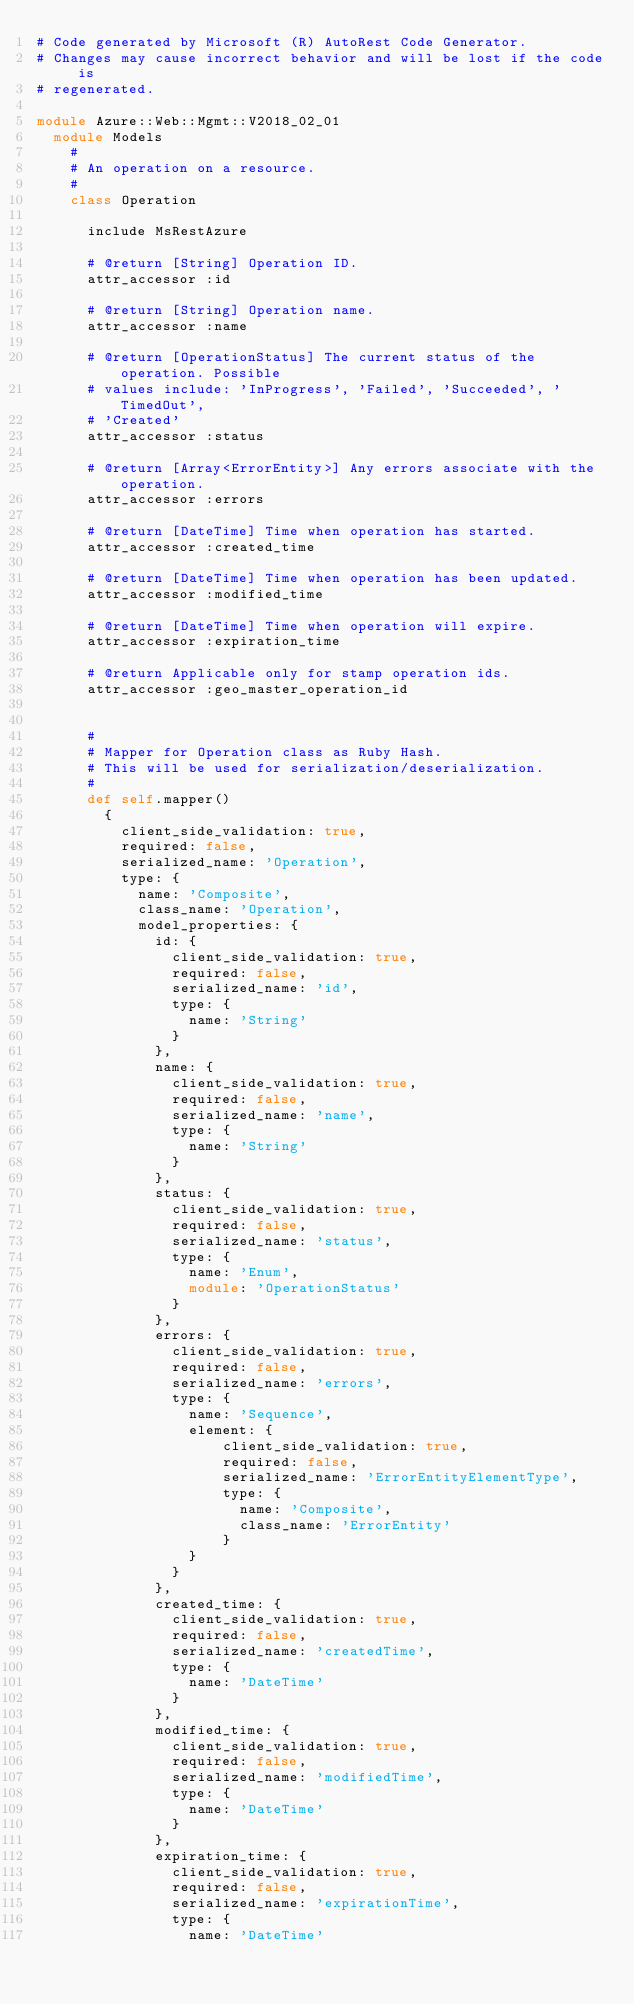Convert code to text. <code><loc_0><loc_0><loc_500><loc_500><_Ruby_># Code generated by Microsoft (R) AutoRest Code Generator.
# Changes may cause incorrect behavior and will be lost if the code is
# regenerated.

module Azure::Web::Mgmt::V2018_02_01
  module Models
    #
    # An operation on a resource.
    #
    class Operation

      include MsRestAzure

      # @return [String] Operation ID.
      attr_accessor :id

      # @return [String] Operation name.
      attr_accessor :name

      # @return [OperationStatus] The current status of the operation. Possible
      # values include: 'InProgress', 'Failed', 'Succeeded', 'TimedOut',
      # 'Created'
      attr_accessor :status

      # @return [Array<ErrorEntity>] Any errors associate with the operation.
      attr_accessor :errors

      # @return [DateTime] Time when operation has started.
      attr_accessor :created_time

      # @return [DateTime] Time when operation has been updated.
      attr_accessor :modified_time

      # @return [DateTime] Time when operation will expire.
      attr_accessor :expiration_time

      # @return Applicable only for stamp operation ids.
      attr_accessor :geo_master_operation_id


      #
      # Mapper for Operation class as Ruby Hash.
      # This will be used for serialization/deserialization.
      #
      def self.mapper()
        {
          client_side_validation: true,
          required: false,
          serialized_name: 'Operation',
          type: {
            name: 'Composite',
            class_name: 'Operation',
            model_properties: {
              id: {
                client_side_validation: true,
                required: false,
                serialized_name: 'id',
                type: {
                  name: 'String'
                }
              },
              name: {
                client_side_validation: true,
                required: false,
                serialized_name: 'name',
                type: {
                  name: 'String'
                }
              },
              status: {
                client_side_validation: true,
                required: false,
                serialized_name: 'status',
                type: {
                  name: 'Enum',
                  module: 'OperationStatus'
                }
              },
              errors: {
                client_side_validation: true,
                required: false,
                serialized_name: 'errors',
                type: {
                  name: 'Sequence',
                  element: {
                      client_side_validation: true,
                      required: false,
                      serialized_name: 'ErrorEntityElementType',
                      type: {
                        name: 'Composite',
                        class_name: 'ErrorEntity'
                      }
                  }
                }
              },
              created_time: {
                client_side_validation: true,
                required: false,
                serialized_name: 'createdTime',
                type: {
                  name: 'DateTime'
                }
              },
              modified_time: {
                client_side_validation: true,
                required: false,
                serialized_name: 'modifiedTime',
                type: {
                  name: 'DateTime'
                }
              },
              expiration_time: {
                client_side_validation: true,
                required: false,
                serialized_name: 'expirationTime',
                type: {
                  name: 'DateTime'</code> 